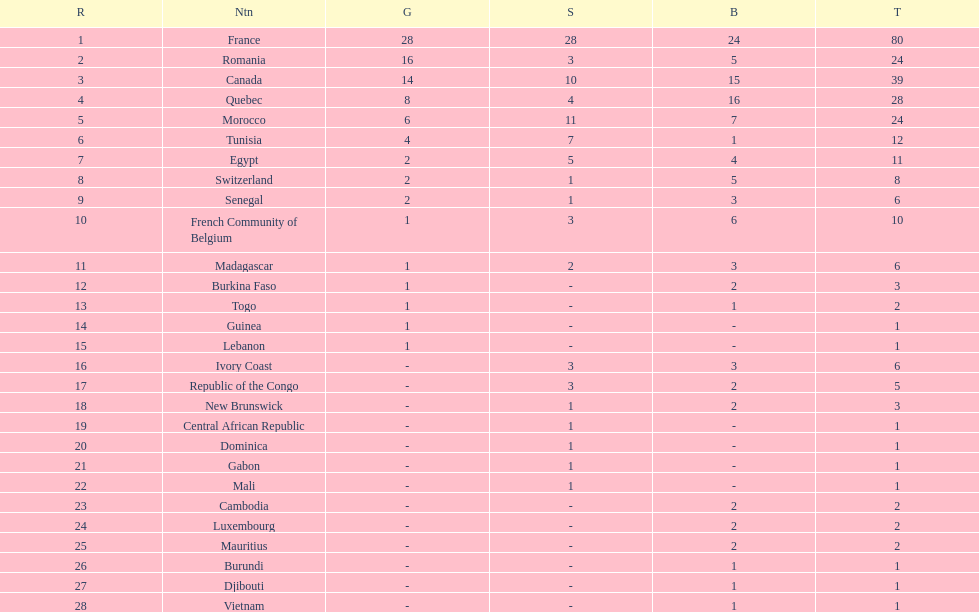What is the difference between france's and egypt's silver medals? 23. 